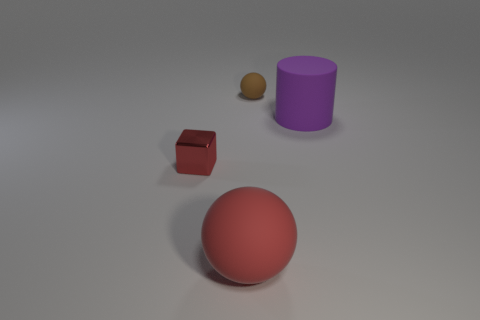Add 2 purple cylinders. How many objects exist? 6 Subtract all cylinders. How many objects are left? 3 Add 1 small balls. How many small balls are left? 2 Add 2 purple rubber cubes. How many purple rubber cubes exist? 2 Subtract 0 purple blocks. How many objects are left? 4 Subtract all rubber cylinders. Subtract all red cubes. How many objects are left? 2 